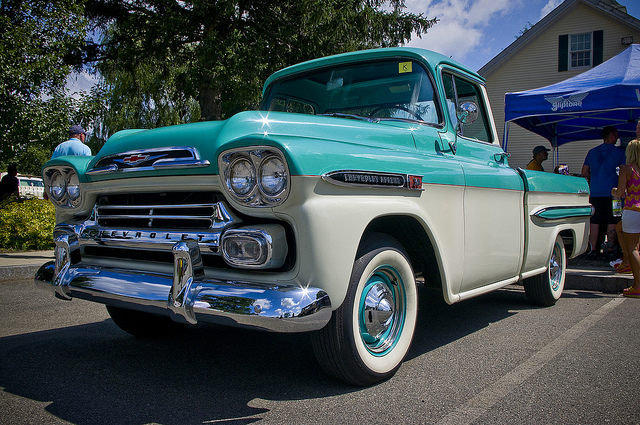Imagine a very creative use for this classic truck in a modern setting. Picture this classic Chevrolet truck converted into a mobile coffee shop that travels to various farmer’s markets and events. The bed of the truck is remodeled to house a vintage-style espresso machine, complete with a wooden counter and seating area to enjoy coffee. The sides are adorned with menu chalkboards and decorative plants, creating a cozy and nostalgic atmosphere. This mobile coffee shop would not only serve delicious beverages but also attract customers with its unique charm and heritage. 